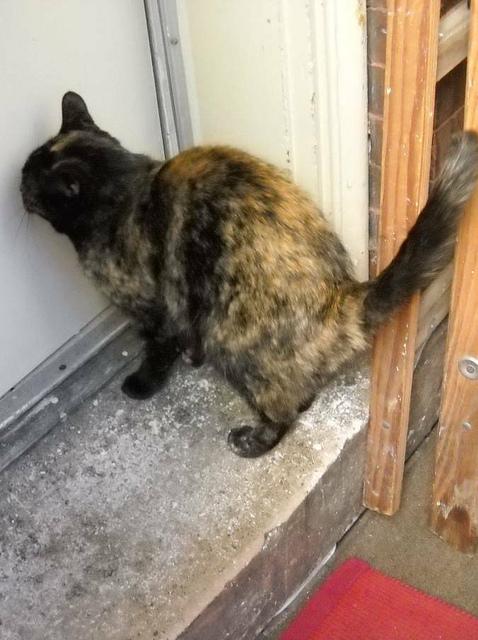Does the cat want to go inside?
Answer briefly. Yes. Is this a dog?
Be succinct. No. What is the item next to the cat?
Write a very short answer. Ladder. 